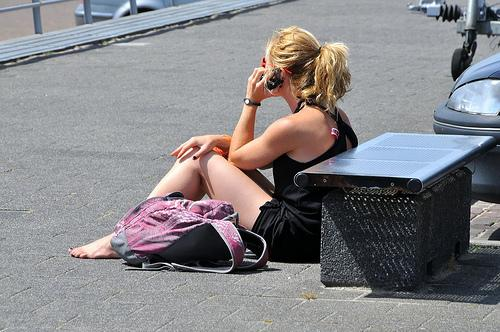What color is the woman's hair, and what is she doing in the image? The woman has blonde hair and she is sitting on the concrete ground talking on her cell phone. What color is the car behind the woman and what part of the car is visible? The car is dark blue, and its front bumper and headlight are visible. How does the woman style her hair in this picture? The woman's hair is styled in a ponytail. Point out any accessories or additional clothing items the woman is using or wearing. The woman has a black wristwatch, a balance bracelet, and a black tank top. What type of shoes is the woman wearing? The woman is not wearing any shoes; she has bare feet. Describe the color and appearance of the surface the woman is sitting on. The woman is sitting on dark grey pavement, which is part of a tile walkway. What type of eyewear does the woman have on, and what color are they? The woman is wearing red sunglasses. Provide a caption for the situation of the woman sitting. Taking a moment to reconnect: A young woman catches up on her calls while enjoying the outdoors. Create a short tagline for an advertisement featuring this scene. Stay Connected Anywhere: A relaxing break outdoors with style and technology at your fingertips. List three objects and their colors that are in the vicinity of the woman. A purple and grey backpack, a dark blue car, and a black bench. 